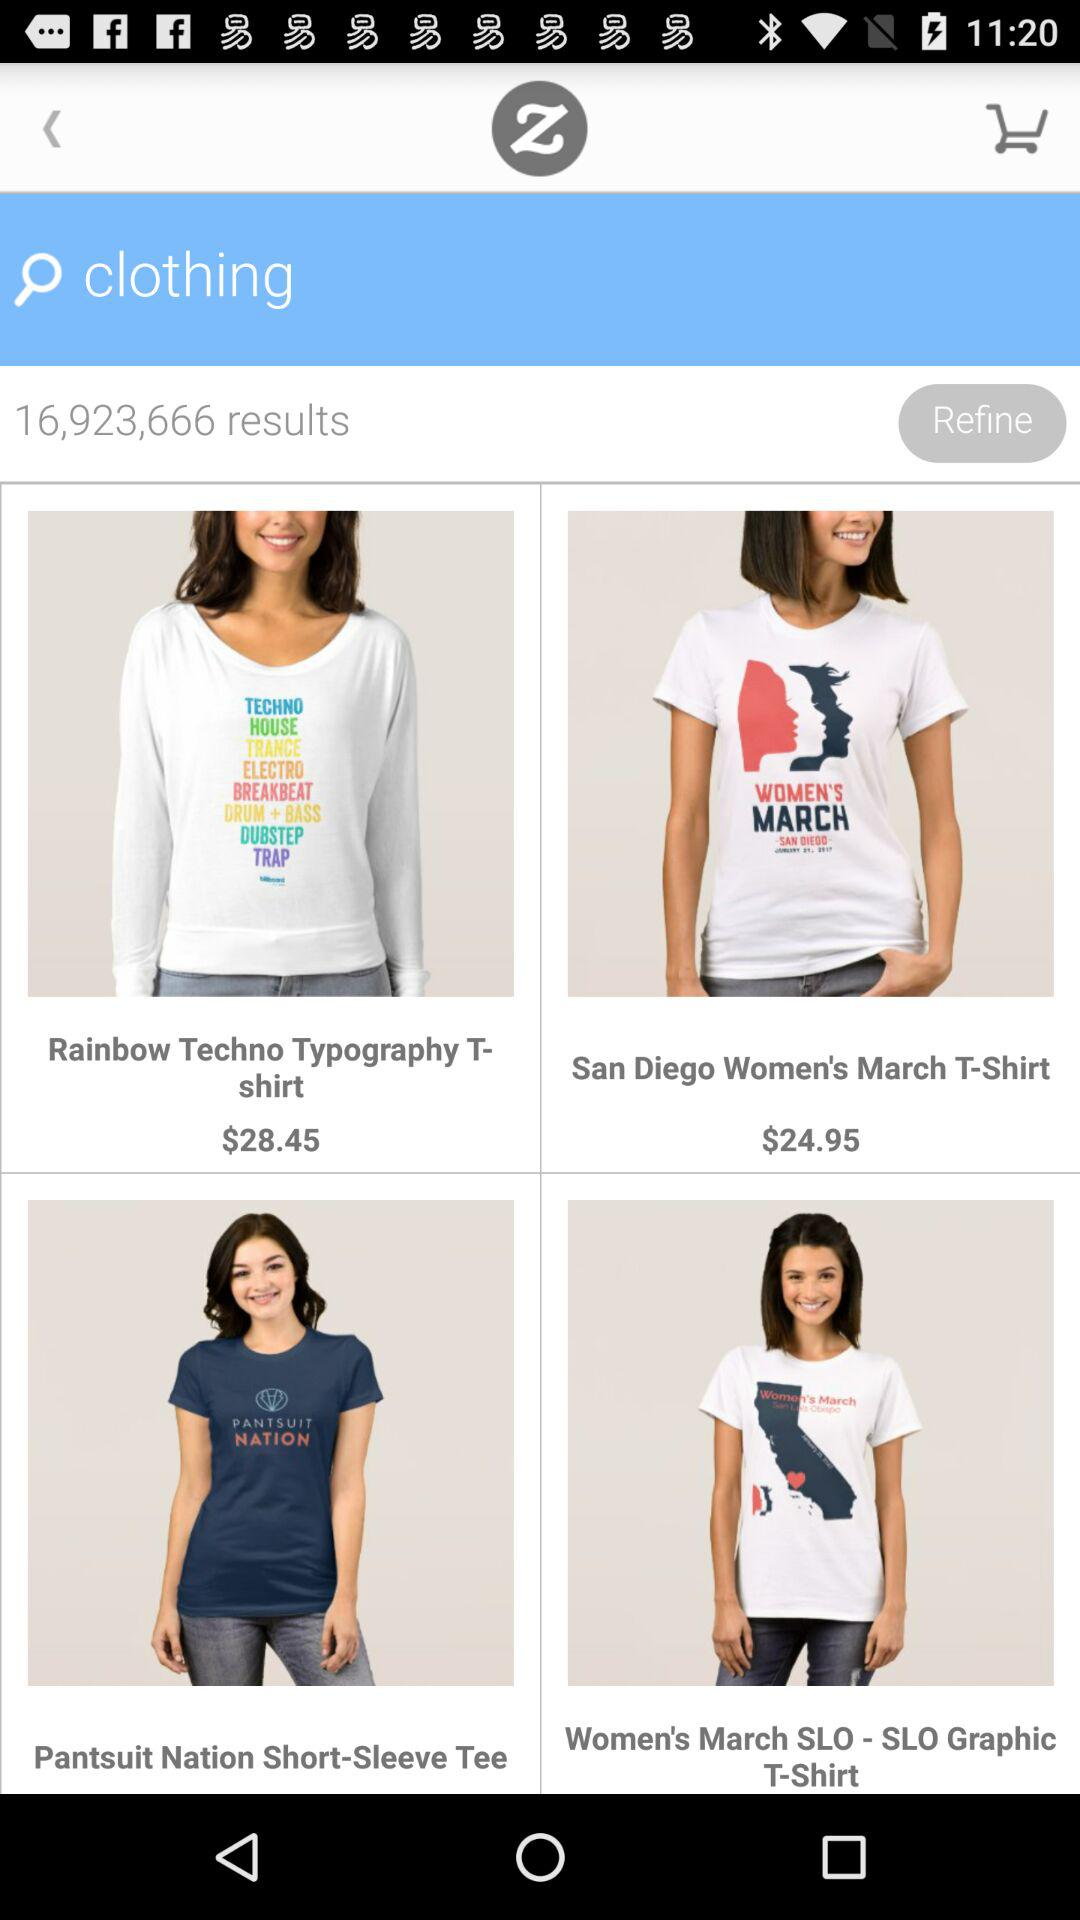How much more expensive is the Rainbow Techno T-shirt than the Women's March T-shirt?
Answer the question using a single word or phrase. $3.50 